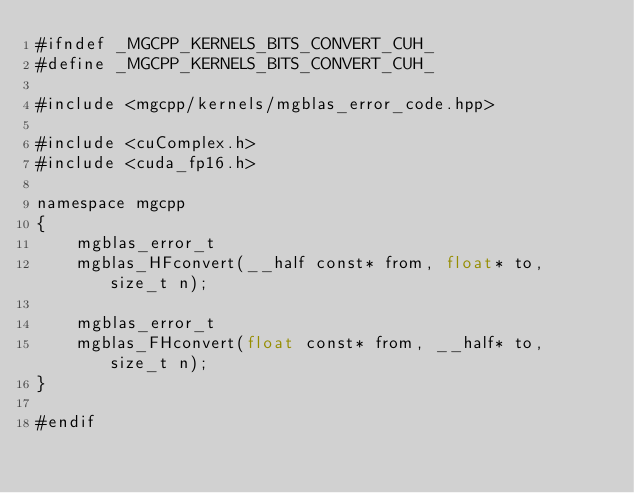<code> <loc_0><loc_0><loc_500><loc_500><_Cuda_>#ifndef _MGCPP_KERNELS_BITS_CONVERT_CUH_
#define _MGCPP_KERNELS_BITS_CONVERT_CUH_

#include <mgcpp/kernels/mgblas_error_code.hpp>

#include <cuComplex.h>
#include <cuda_fp16.h>

namespace mgcpp
{
    mgblas_error_t
    mgblas_HFconvert(__half const* from, float* to, size_t n);

    mgblas_error_t
    mgblas_FHconvert(float const* from, __half* to, size_t n);
}

#endif
</code> 